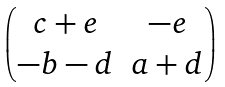<formula> <loc_0><loc_0><loc_500><loc_500>\begin{pmatrix} c + e & - e \\ - b - d & a + d \end{pmatrix}</formula> 